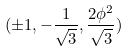Convert formula to latex. <formula><loc_0><loc_0><loc_500><loc_500>( \pm 1 , - \frac { 1 } { \sqrt { 3 } } , \frac { 2 \phi ^ { 2 } } { \sqrt { 3 } } )</formula> 